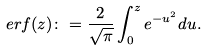Convert formula to latex. <formula><loc_0><loc_0><loc_500><loc_500>\ e r f ( z ) \colon = \frac { 2 } { \sqrt { \pi } } \int _ { 0 } ^ { z } e ^ { - u ^ { 2 } } d u .</formula> 